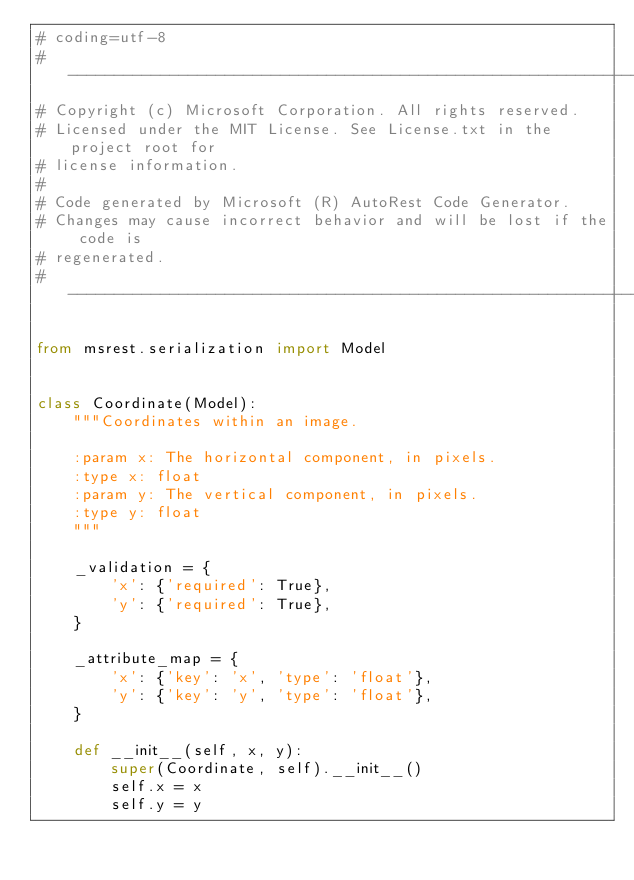Convert code to text. <code><loc_0><loc_0><loc_500><loc_500><_Python_># coding=utf-8
# --------------------------------------------------------------------------
# Copyright (c) Microsoft Corporation. All rights reserved.
# Licensed under the MIT License. See License.txt in the project root for
# license information.
#
# Code generated by Microsoft (R) AutoRest Code Generator.
# Changes may cause incorrect behavior and will be lost if the code is
# regenerated.
# --------------------------------------------------------------------------

from msrest.serialization import Model


class Coordinate(Model):
    """Coordinates within an image.

    :param x: The horizontal component, in pixels.
    :type x: float
    :param y: The vertical component, in pixels.
    :type y: float
    """

    _validation = {
        'x': {'required': True},
        'y': {'required': True},
    }

    _attribute_map = {
        'x': {'key': 'x', 'type': 'float'},
        'y': {'key': 'y', 'type': 'float'},
    }

    def __init__(self, x, y):
        super(Coordinate, self).__init__()
        self.x = x
        self.y = y
</code> 